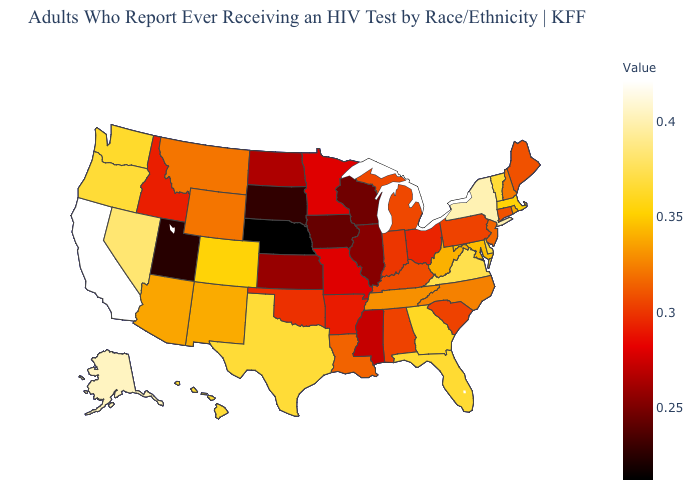Does California have the highest value in the USA?
Keep it brief. Yes. Does the map have missing data?
Concise answer only. No. Does Hawaii have a higher value than Wisconsin?
Short answer required. Yes. Does Montana have the lowest value in the West?
Concise answer only. No. Does Wisconsin have a higher value than Utah?
Concise answer only. Yes. Which states hav the highest value in the MidWest?
Be succinct. Michigan. 